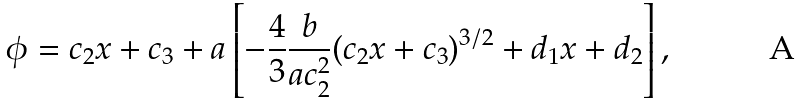<formula> <loc_0><loc_0><loc_500><loc_500>\phi = c _ { 2 } x + c _ { 3 } + a \left [ - \frac { 4 } { 3 } \frac { b } { a c _ { 2 } ^ { 2 } } ( c _ { 2 } x + c _ { 3 } ) ^ { 3 / 2 } + d _ { 1 } x + d _ { 2 } \right ] ,</formula> 